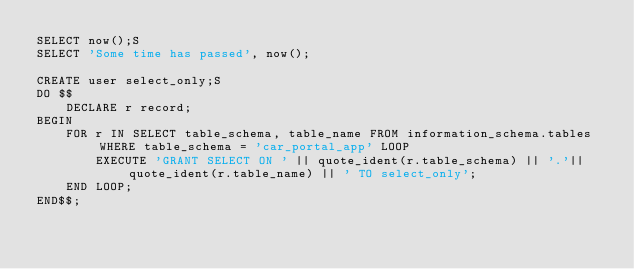Convert code to text. <code><loc_0><loc_0><loc_500><loc_500><_SQL_>SELECT now();S
SELECT 'Some time has passed', now();

CREATE user select_only;S
DO $$
    DECLARE r record;
BEGIN
    FOR r IN SELECT table_schema, table_name FROM information_schema.tables WHERE table_schema = 'car_portal_app' LOOP
        EXECUTE 'GRANT SELECT ON ' || quote_ident(r.table_schema) || '.'|| quote_ident(r.table_name) || ' TO select_only';
    END LOOP;
END$$;
</code> 